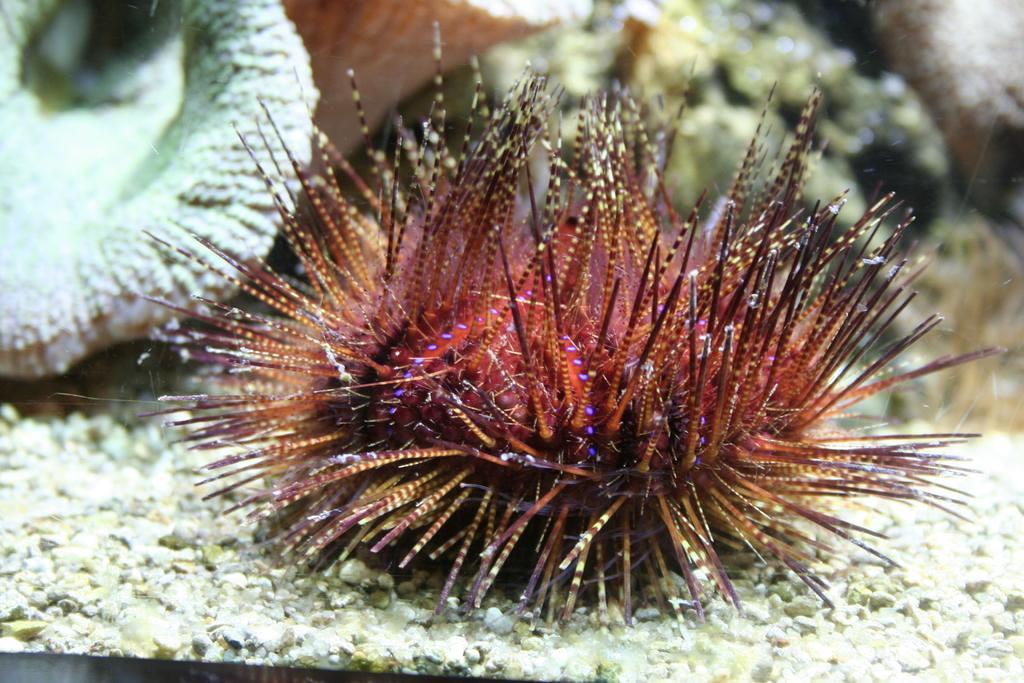Please provide a concise description of this image. In this picture there is a marine biology in the image. 